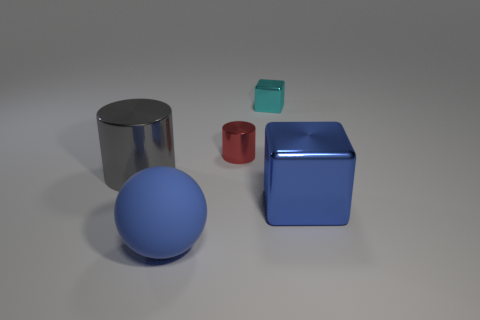What number of other things are there of the same size as the matte sphere?
Provide a succinct answer. 2. There is a small shiny thing that is to the left of the small cyan block; does it have the same color as the large shiny cylinder?
Keep it short and to the point. No. Is the number of tiny red cylinders left of the large blue rubber ball greater than the number of gray rubber cylinders?
Ensure brevity in your answer.  No. Are there any other things that have the same color as the large ball?
Give a very brief answer. Yes. What shape is the thing in front of the block in front of the cyan shiny cube?
Ensure brevity in your answer.  Sphere. Is the number of big brown blocks greater than the number of tiny cyan cubes?
Your answer should be compact. No. What number of things are in front of the big blue block and behind the large cylinder?
Offer a terse response. 0. There is a thing that is in front of the blue metallic cube; how many blue matte objects are to the right of it?
Give a very brief answer. 0. What number of things are large blue objects that are right of the big blue ball or things behind the large gray cylinder?
Your response must be concise. 3. There is a blue object that is the same shape as the small cyan thing; what is its material?
Give a very brief answer. Metal. 